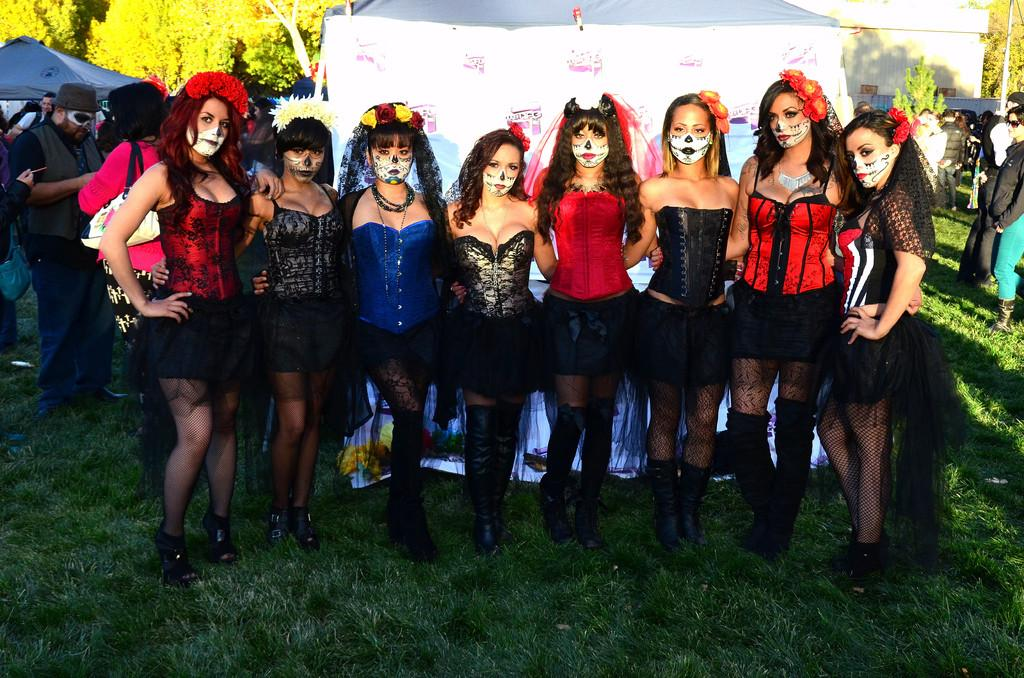What is the main subject of the image? The main subject of the image is the women standing in the center. Where are the women standing? The women are standing on the grass. What can be seen in the background of the image? There are tents, a house, and trees in the background of the image. Are there any other people visible in the image? Yes, there are persons in the background of the image. What type of record is being played by the women in the image? There is no record or music player visible in the image, so it cannot be determined if a record is being played. 